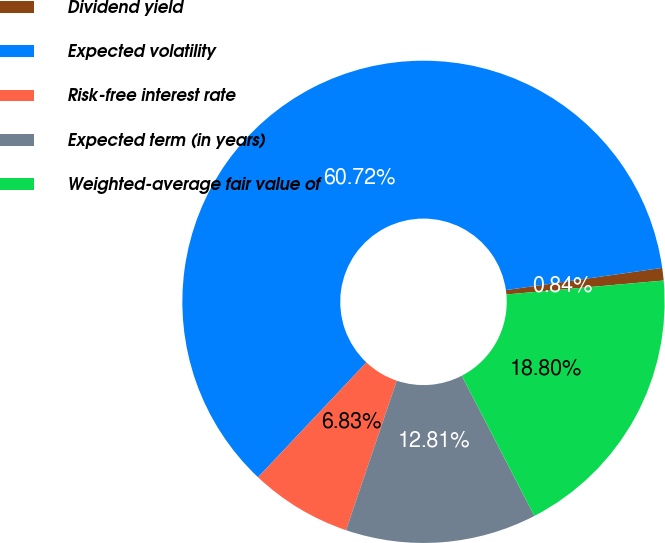Convert chart. <chart><loc_0><loc_0><loc_500><loc_500><pie_chart><fcel>Dividend yield<fcel>Expected volatility<fcel>Risk-free interest rate<fcel>Expected term (in years)<fcel>Weighted-average fair value of<nl><fcel>0.84%<fcel>60.72%<fcel>6.83%<fcel>12.81%<fcel>18.8%<nl></chart> 